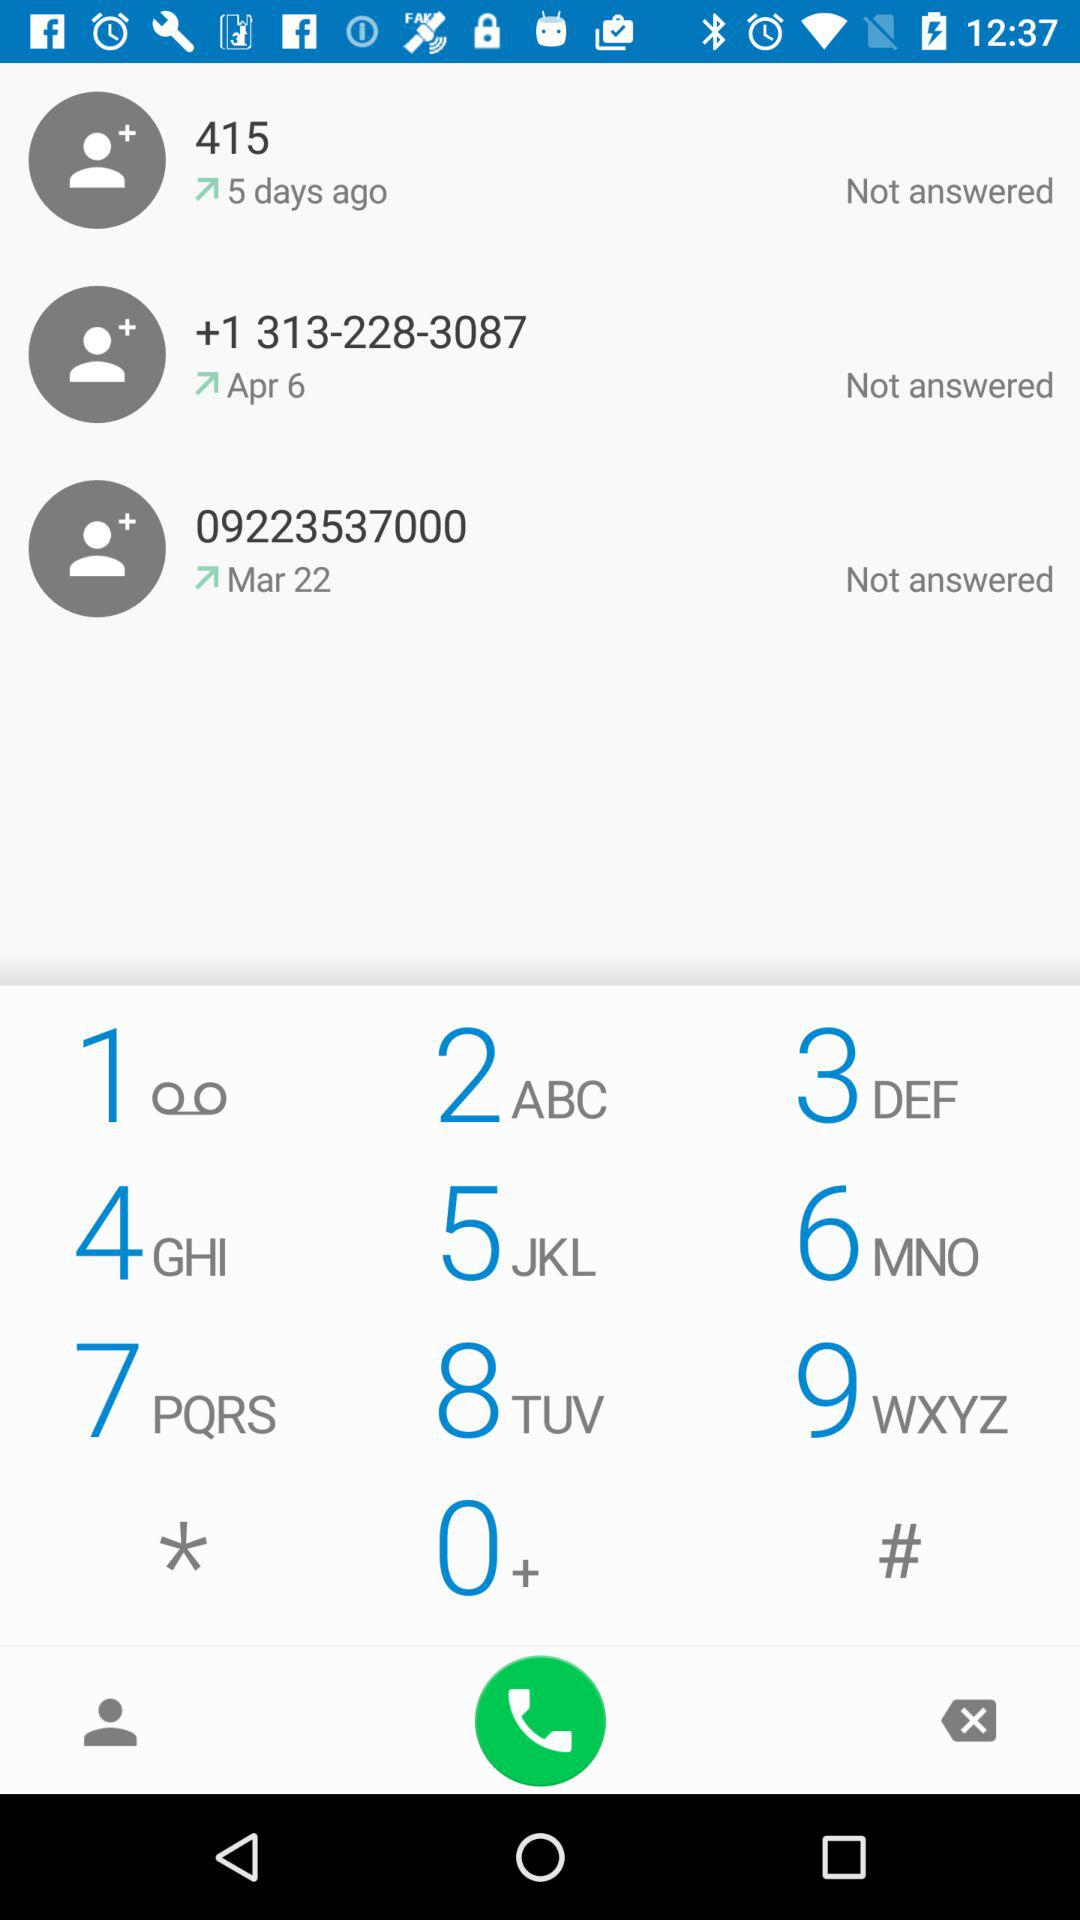From what number did I get the call 5 days ago? The number is 415. 